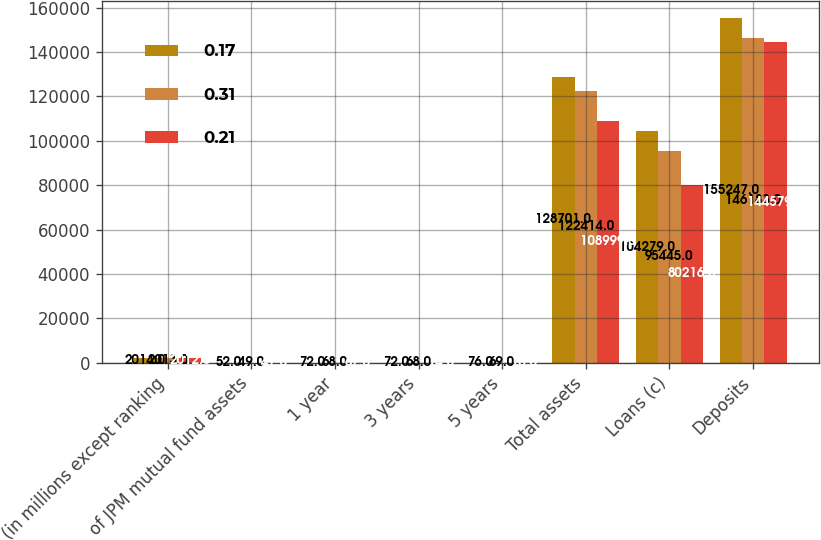Convert chart to OTSL. <chart><loc_0><loc_0><loc_500><loc_500><stacked_bar_chart><ecel><fcel>(in millions except ranking<fcel>of JPM mutual fund assets<fcel>1 year<fcel>3 years<fcel>5 years<fcel>Total assets<fcel>Loans (c)<fcel>Deposits<nl><fcel>0.17<fcel>2014<fcel>52<fcel>72<fcel>72<fcel>76<fcel>128701<fcel>104279<fcel>155247<nl><fcel>0.31<fcel>2013<fcel>49<fcel>68<fcel>68<fcel>69<fcel>122414<fcel>95445<fcel>146183<nl><fcel>0.21<fcel>2012<fcel>47<fcel>67<fcel>74<fcel>76<fcel>108999<fcel>80216<fcel>144579<nl></chart> 